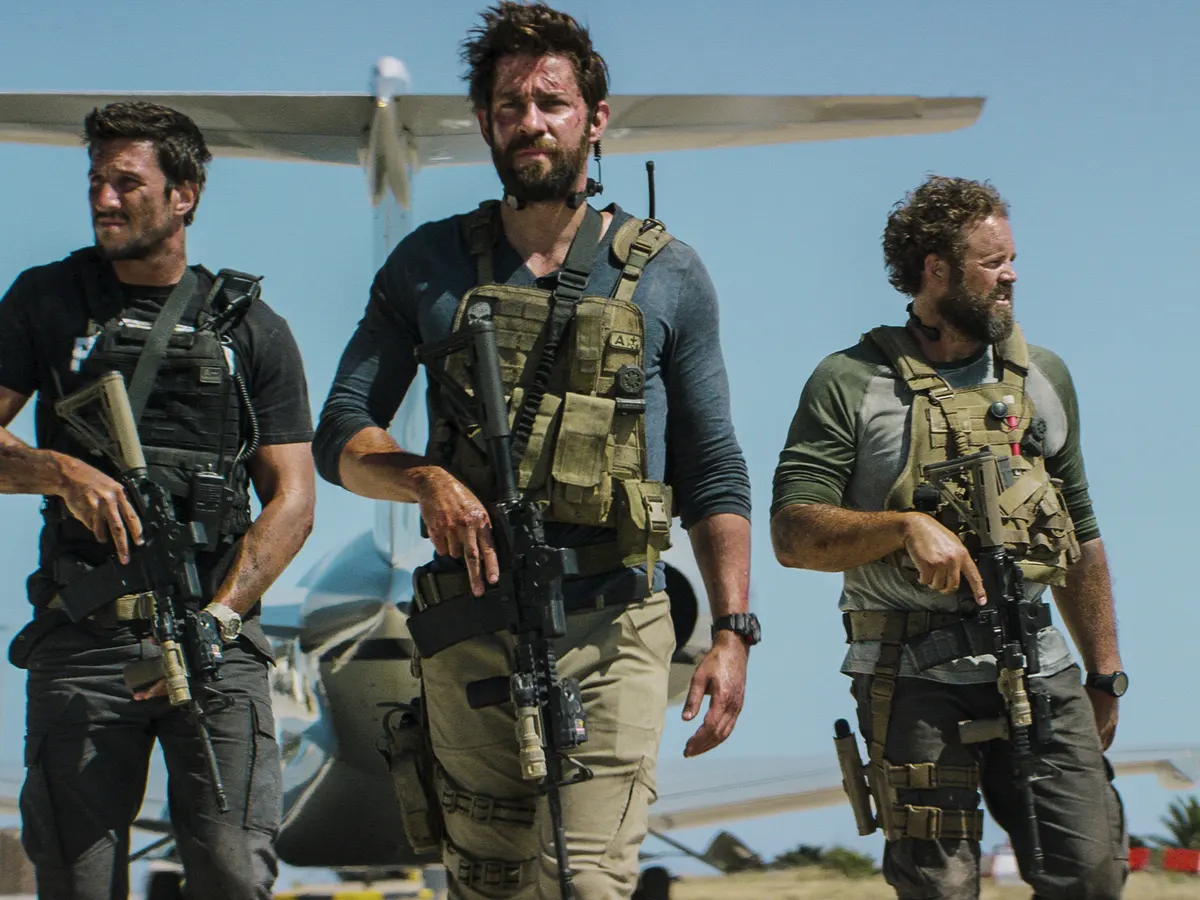Explain the visual content of the image in great detail. In the image, actor John Krasinski is captured in a moment of intense focus. He is centrally positioned, walking towards the camera with a serious expression etched on his face. His attire is a beige tactical vest, and he's armed with a rifle, suggesting a scene of action or conflict. Flanking him on both sides are two other men, similarly dressed in tactical gear and carrying rifles, their faces set with determination. The trio appears to be part of a coordinated unit, moving in unison across a sandy ground. In the backdrop, a small airplane rests on a runway under the clear blue sky, adding to the sense of location and context. 